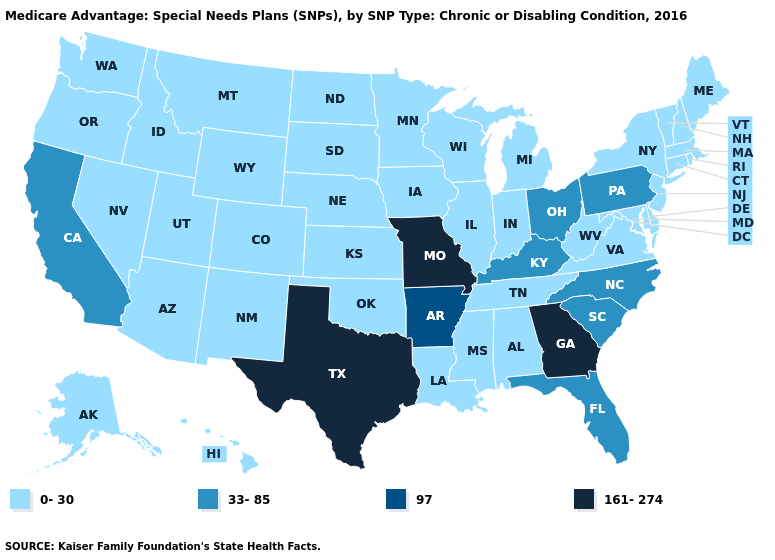Name the states that have a value in the range 97?
Be succinct. Arkansas. Which states have the lowest value in the USA?
Give a very brief answer. Alaska, Alabama, Arizona, Colorado, Connecticut, Delaware, Hawaii, Iowa, Idaho, Illinois, Indiana, Kansas, Louisiana, Massachusetts, Maryland, Maine, Michigan, Minnesota, Mississippi, Montana, North Dakota, Nebraska, New Hampshire, New Jersey, New Mexico, Nevada, New York, Oklahoma, Oregon, Rhode Island, South Dakota, Tennessee, Utah, Virginia, Vermont, Washington, Wisconsin, West Virginia, Wyoming. What is the value of California?
Short answer required. 33-85. Name the states that have a value in the range 0-30?
Answer briefly. Alaska, Alabama, Arizona, Colorado, Connecticut, Delaware, Hawaii, Iowa, Idaho, Illinois, Indiana, Kansas, Louisiana, Massachusetts, Maryland, Maine, Michigan, Minnesota, Mississippi, Montana, North Dakota, Nebraska, New Hampshire, New Jersey, New Mexico, Nevada, New York, Oklahoma, Oregon, Rhode Island, South Dakota, Tennessee, Utah, Virginia, Vermont, Washington, Wisconsin, West Virginia, Wyoming. What is the value of Washington?
Keep it brief. 0-30. Does North Carolina have a lower value than Virginia?
Quick response, please. No. Among the states that border Michigan , which have the lowest value?
Be succinct. Indiana, Wisconsin. Among the states that border Oregon , which have the lowest value?
Keep it brief. Idaho, Nevada, Washington. Which states have the highest value in the USA?
Be succinct. Georgia, Missouri, Texas. Name the states that have a value in the range 97?
Short answer required. Arkansas. Name the states that have a value in the range 97?
Quick response, please. Arkansas. Which states have the lowest value in the USA?
Give a very brief answer. Alaska, Alabama, Arizona, Colorado, Connecticut, Delaware, Hawaii, Iowa, Idaho, Illinois, Indiana, Kansas, Louisiana, Massachusetts, Maryland, Maine, Michigan, Minnesota, Mississippi, Montana, North Dakota, Nebraska, New Hampshire, New Jersey, New Mexico, Nevada, New York, Oklahoma, Oregon, Rhode Island, South Dakota, Tennessee, Utah, Virginia, Vermont, Washington, Wisconsin, West Virginia, Wyoming. Does Pennsylvania have the lowest value in the Northeast?
Be succinct. No. Which states hav the highest value in the Northeast?
Keep it brief. Pennsylvania. 